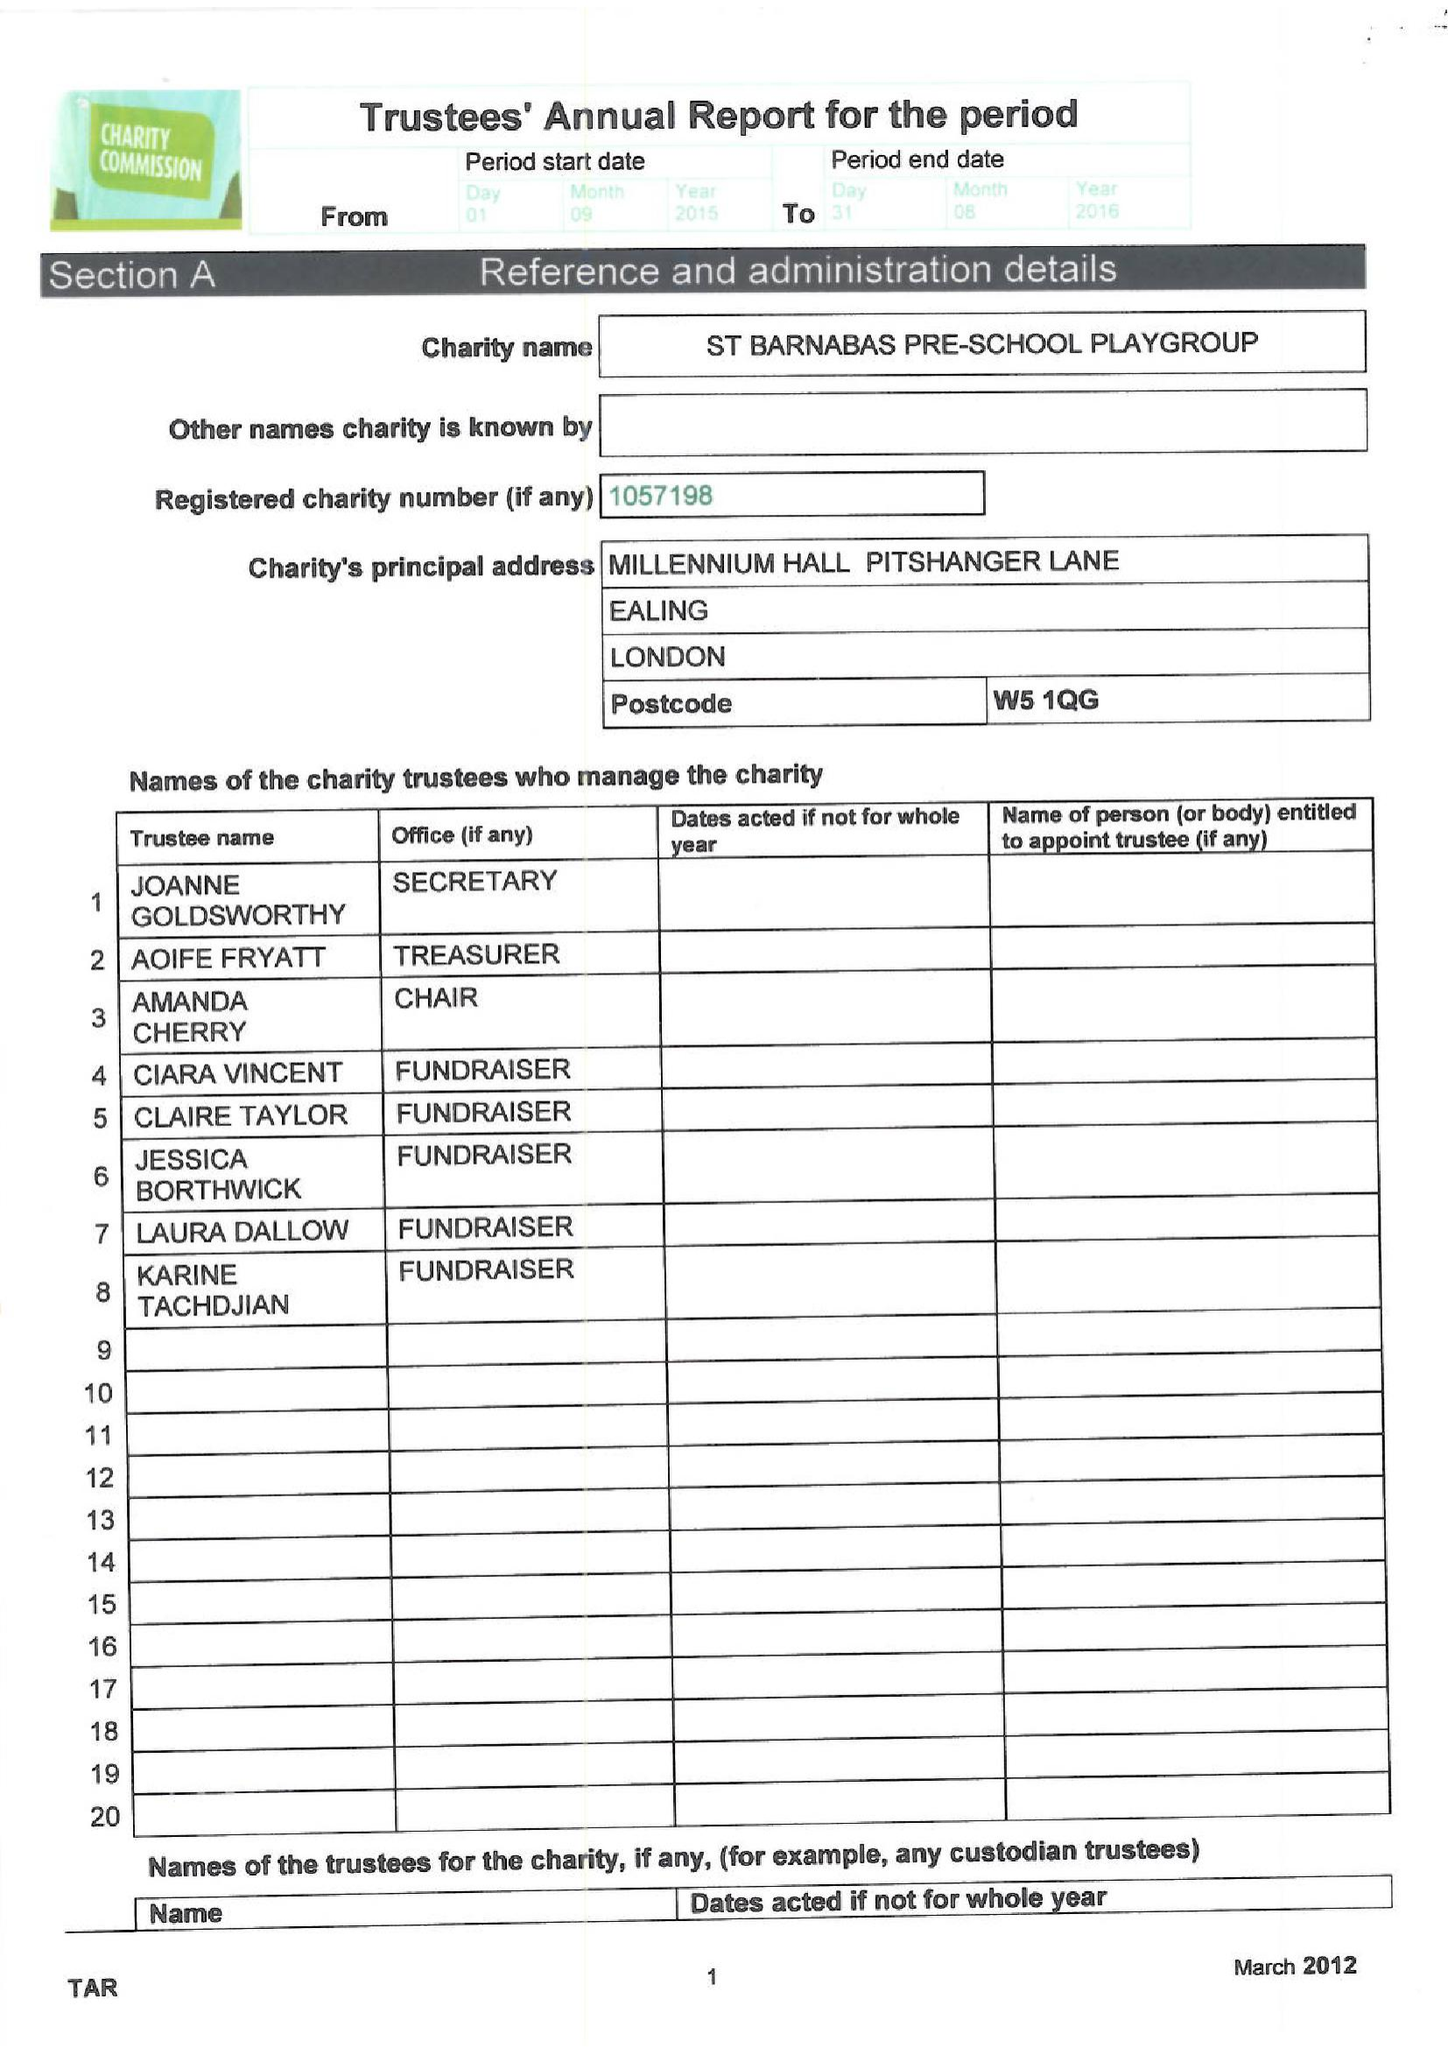What is the value for the spending_annually_in_british_pounds?
Answer the question using a single word or phrase. 53261.00 